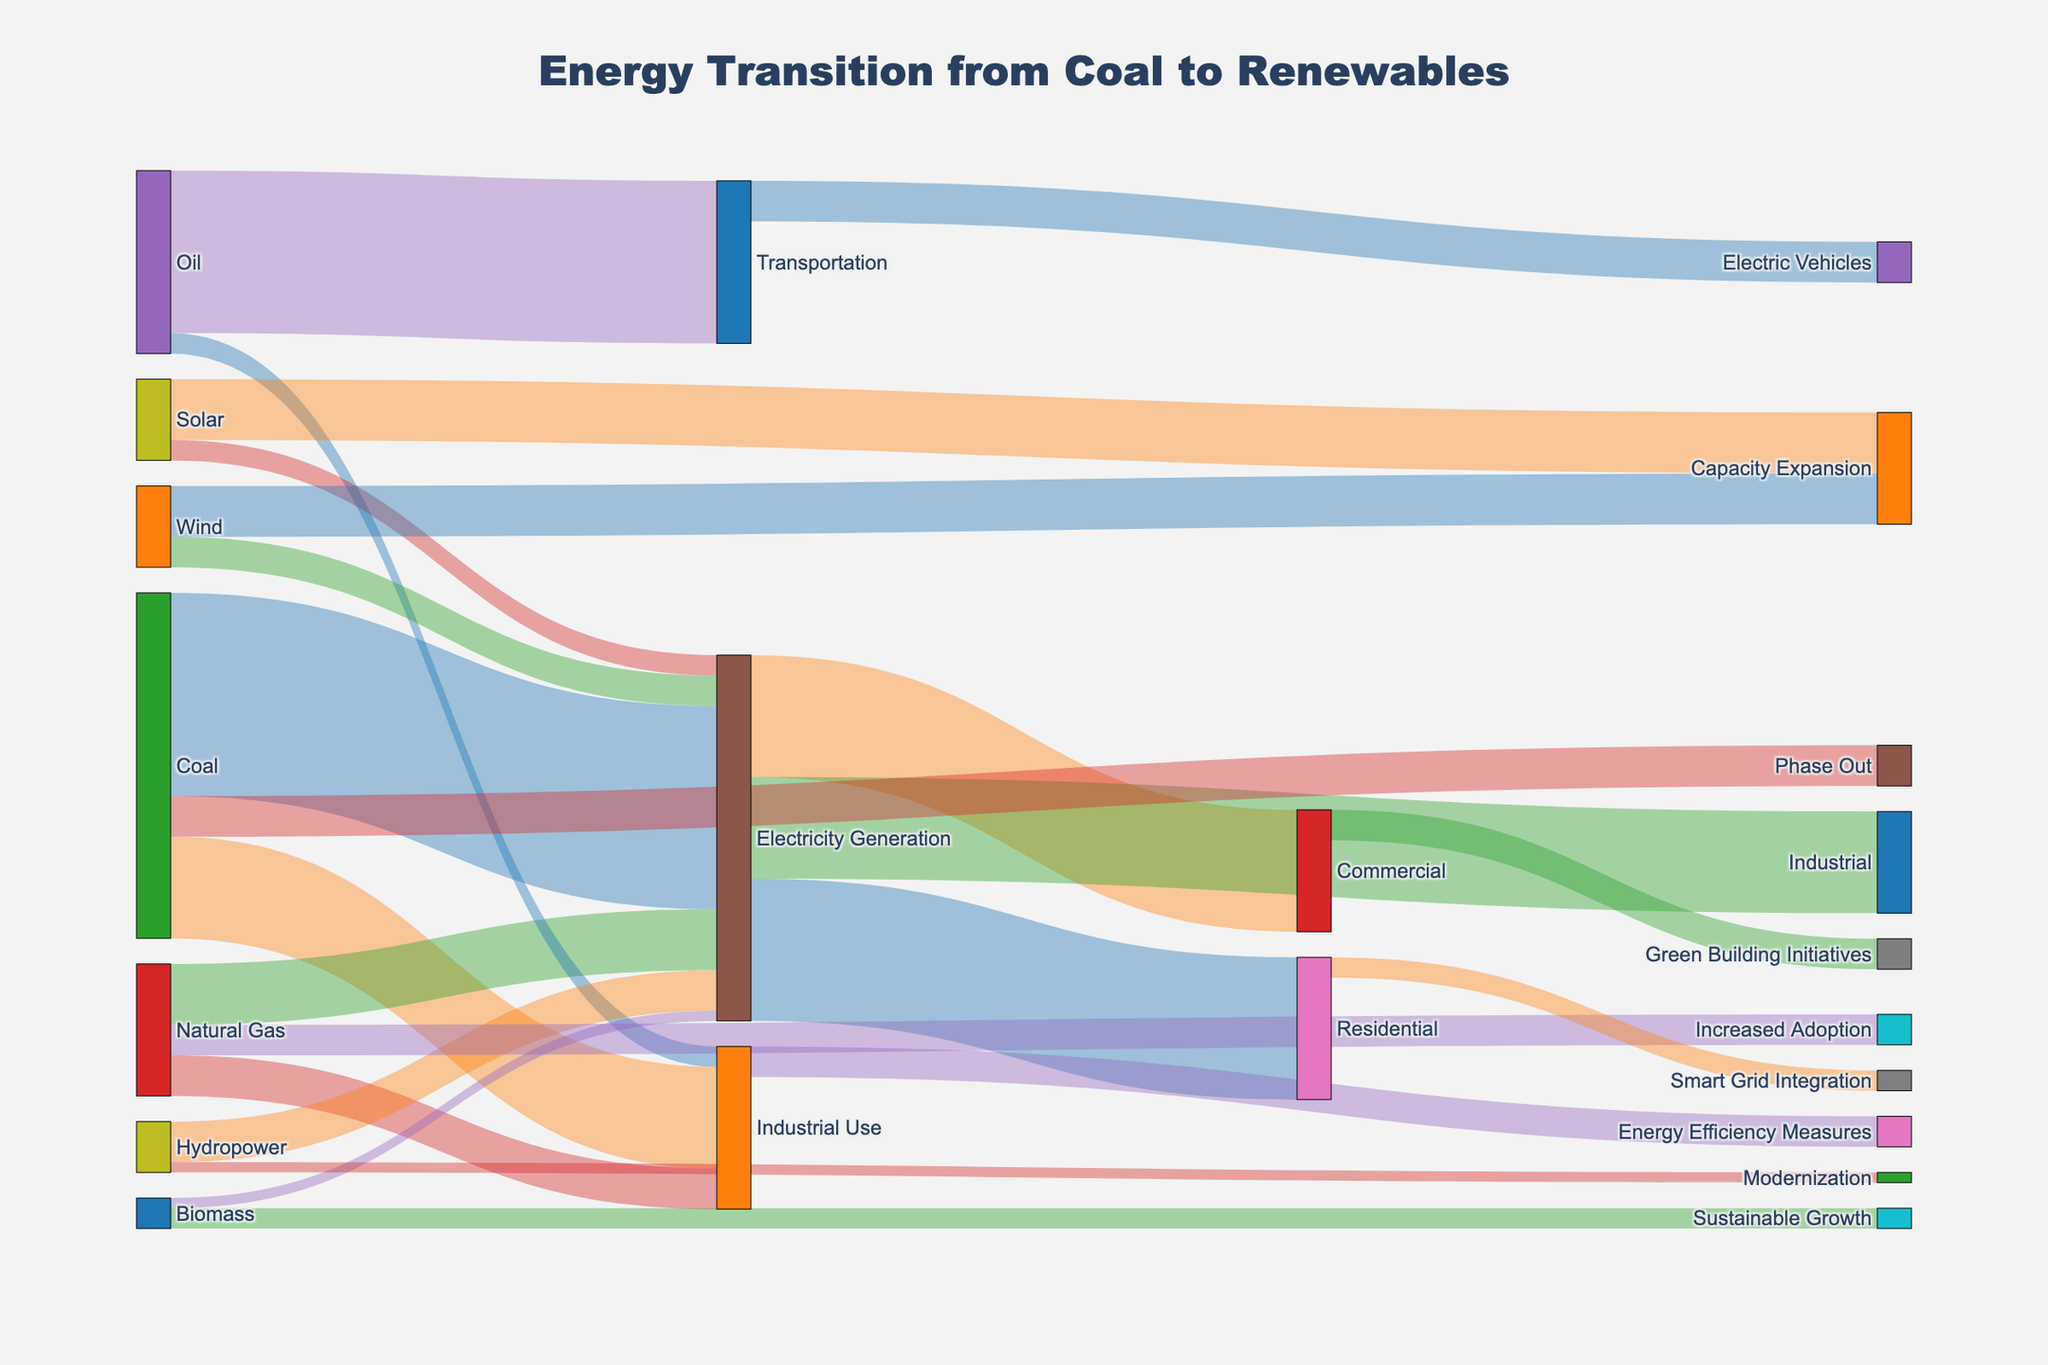What is the primary source for electricity generation? The primary source is the energy source that contributes the most to electricity generation. By looking at the thickness of the flow lines leading to "Electricity Generation," we can see that "Coal" has the thickest line.
Answer: Coal How much energy from coal is used for electricity generation and industrial use combined? To find this, sum the values for "Coal" to "Electricity Generation" and "Coal" to "Industrial Use." These are 100 and 50, respectively, so the total is 100 + 50 = 150.
Answer: 150 Which renewable energy sources are contributing to electricity generation? By examining the lines leading to "Electricity Generation" from renewable sources, we identify "Hydropower," "Wind," "Solar," and "Biomass."
Answer: Hydropower, Wind, Solar, Biomass Does natural gas have a greater value for electricity generation or industrial use? Compare the flow values of "Natural Gas" to "Electricity Generation" (30) and "Natural Gas" to "Industrial Use" (20). Since 30 is greater than 20, natural gas contributes more to electricity generation.
Answer: Electricity Generation What is the total amount of energy supplied by renewable sources for electricity generation? Sum the values of "Hydropower," "Wind," "Solar," and "Biomass" leading to "Electricity Generation." These values are 20, 15, 10, and 5, respectively, so the total is 20 + 15 + 10 + 5 = 50.
Answer: 50 Which sector uses the most electricity? By looking at the flow lines from "Electricity Generation," we compare the values for "Residential" (70), "Commercial" (60), and "Industrial" (50). The "Residential" sector uses the most electricity.
Answer: Residential What energy source is being phased out? The flow labeled "Phase Out" shows that "Coal" is the energy source being phased out.
Answer: Coal How does the value for oil used in transportation compare to the total value for oil used in all sectors? The value for "Oil" in "Transportation" is 80. The total value of "Oil" used is the sum of "Oil" to "Transportation" (80) and "Oil" to "Industrial Use" (10). So, the total is 80 + 10 = 90. Compare 80 to 90; the value for transportation is 80/90 of the total, which is 88.89%.
Answer: 88.89% What are the measures being taken for energy efficiency in industrial use? By following the flow from "Industrial Use," we see the label "Energy Efficiency Measures" associated with 15 units.
Answer: Energy Efficiency Measures How many more units of energy are used for residential purposes than for commercial purposes? Compare the units for residential (70) against commercial (60), and calculate the difference: 70 - 60 = 10.
Answer: 10 